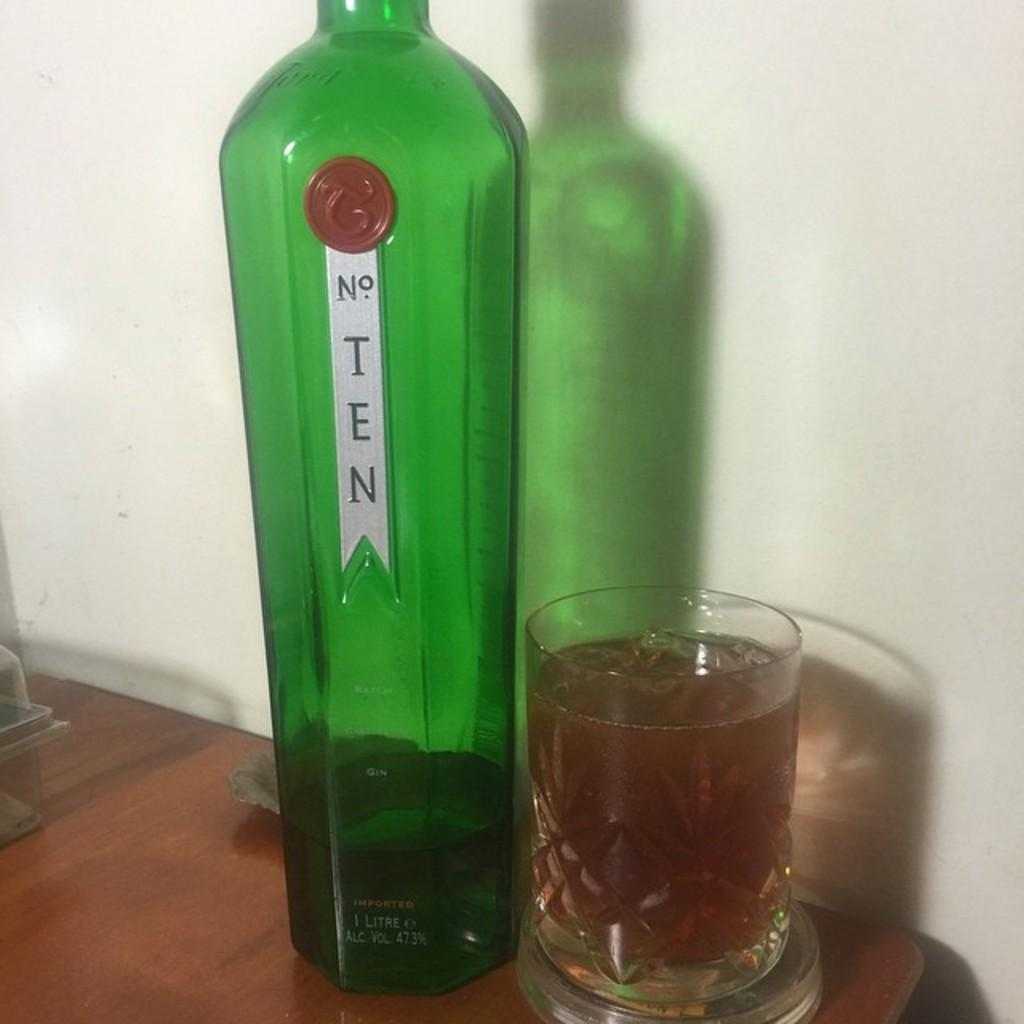What is present on the table in the image? There is a bottle and a glass on the table in the image. What might be contained in the bottle and the glass? It is not specified what is contained in the bottle and the glass, but they are typically used for holding liquids. Can you describe the location of the bottle and the glass? Both the bottle and the glass are on a table in the image. What type of payment is required to move the bottle and the glass in the image? There is no payment required to move the bottle and the glass in the image, as they are stationary objects. 